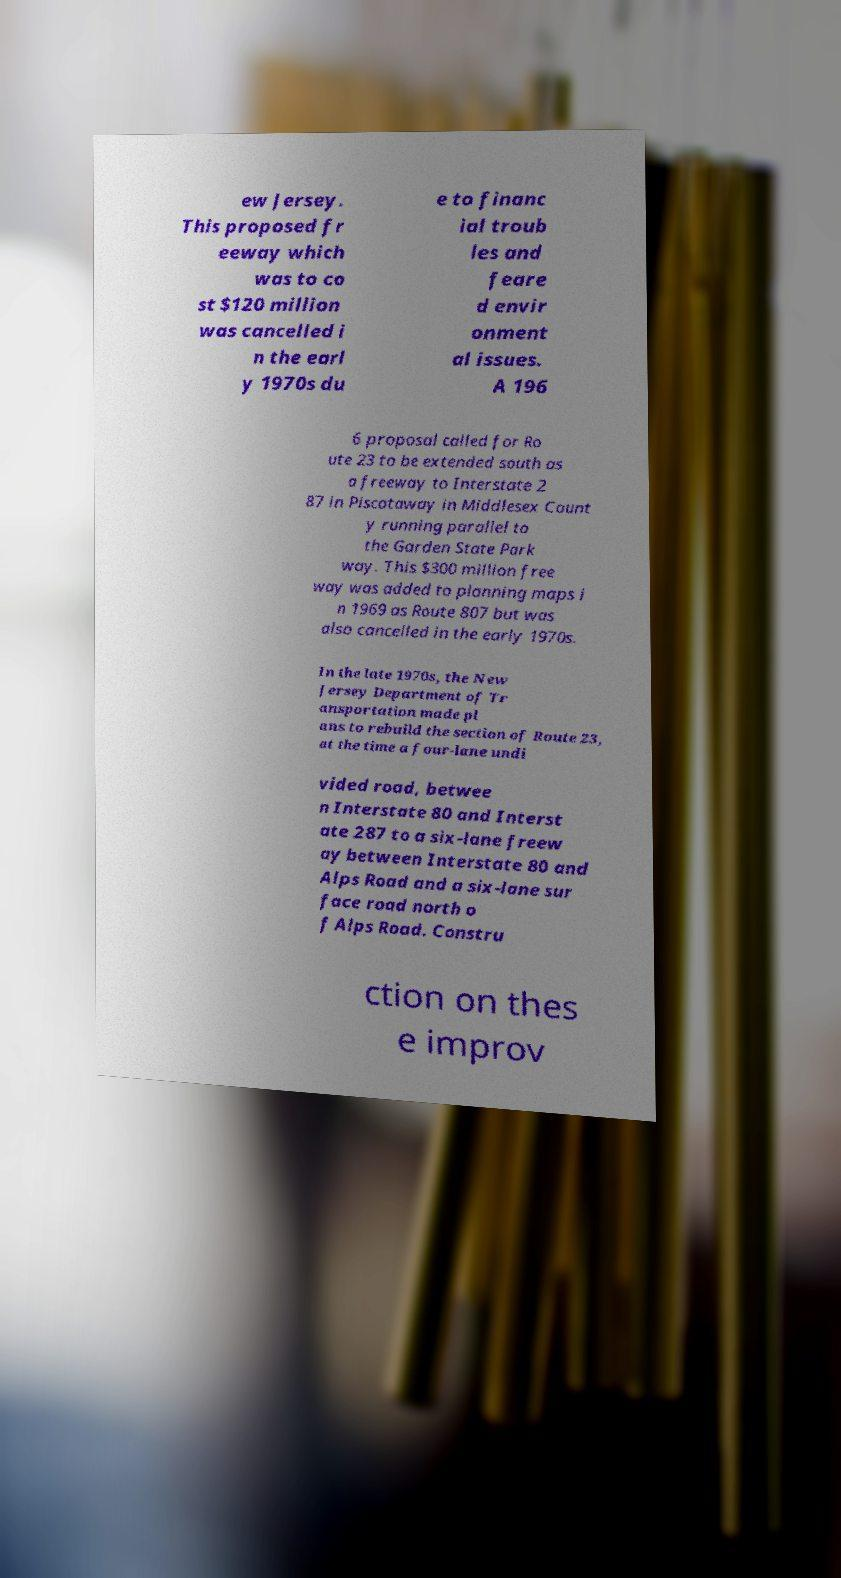Can you accurately transcribe the text from the provided image for me? ew Jersey. This proposed fr eeway which was to co st $120 million was cancelled i n the earl y 1970s du e to financ ial troub les and feare d envir onment al issues. A 196 6 proposal called for Ro ute 23 to be extended south as a freeway to Interstate 2 87 in Piscataway in Middlesex Count y running parallel to the Garden State Park way. This $300 million free way was added to planning maps i n 1969 as Route 807 but was also cancelled in the early 1970s. In the late 1970s, the New Jersey Department of Tr ansportation made pl ans to rebuild the section of Route 23, at the time a four-lane undi vided road, betwee n Interstate 80 and Interst ate 287 to a six-lane freew ay between Interstate 80 and Alps Road and a six-lane sur face road north o f Alps Road. Constru ction on thes e improv 